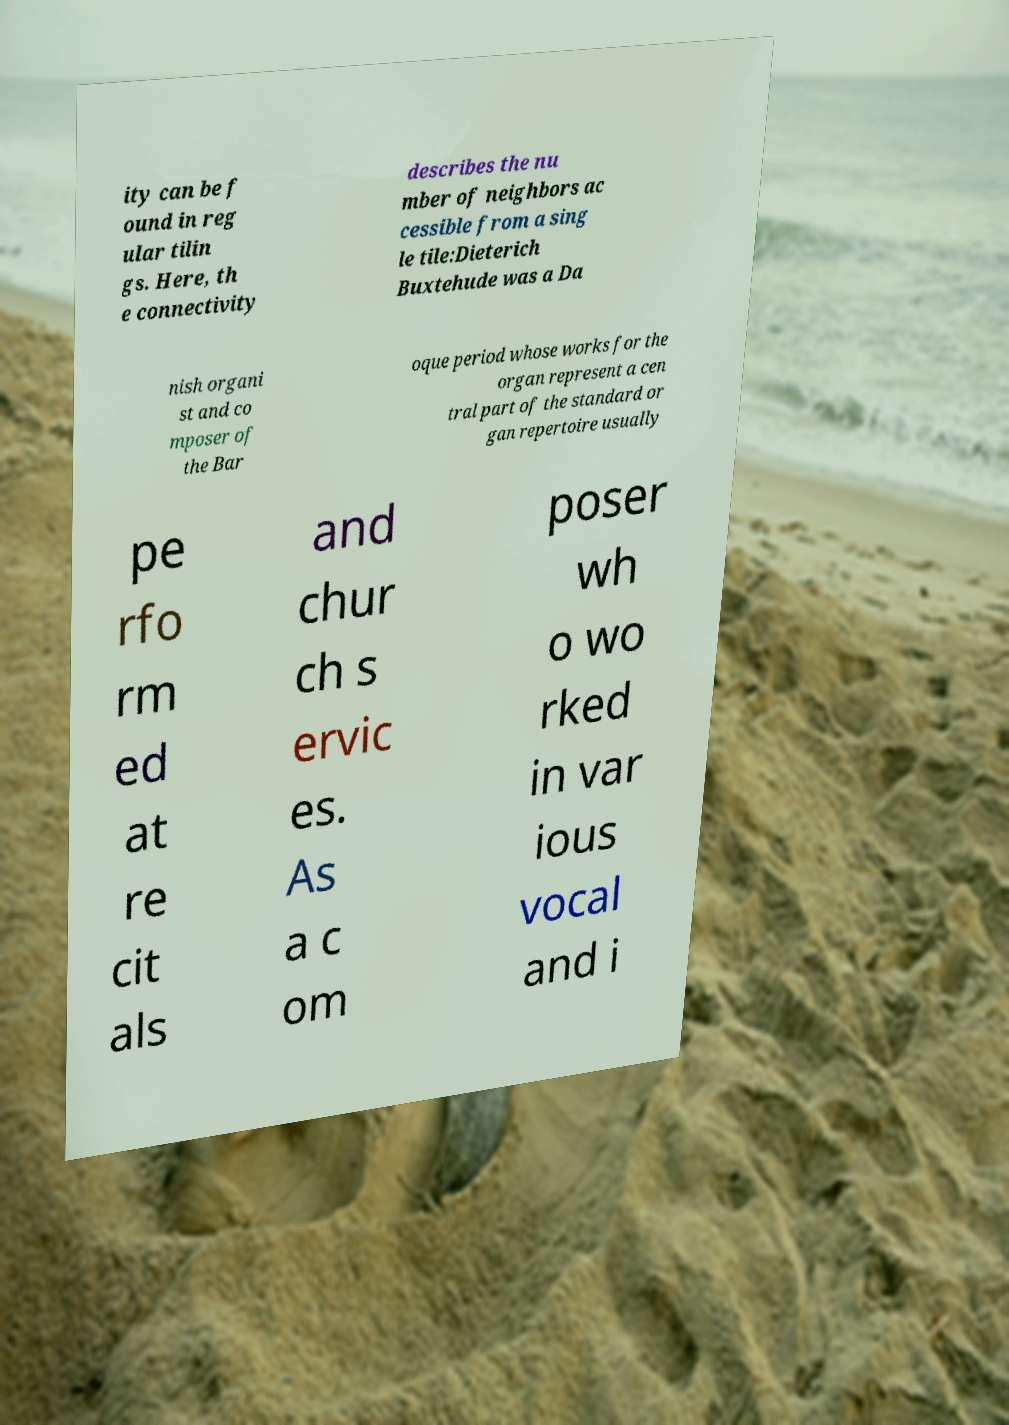Could you extract and type out the text from this image? ity can be f ound in reg ular tilin gs. Here, th e connectivity describes the nu mber of neighbors ac cessible from a sing le tile:Dieterich Buxtehude was a Da nish organi st and co mposer of the Bar oque period whose works for the organ represent a cen tral part of the standard or gan repertoire usually pe rfo rm ed at re cit als and chur ch s ervic es. As a c om poser wh o wo rked in var ious vocal and i 